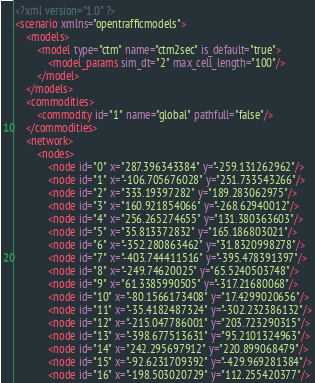<code> <loc_0><loc_0><loc_500><loc_500><_XML_><?xml version="1.0" ?>
<scenario xmlns="opentrafficmodels">
	<models>
		<model type="ctm" name="ctm2sec" is_default="true">
			<model_params sim_dt="2" max_cell_length="100"/>
		</model>
	</models>
	<commodities>
		<commodity id="1" name="global" pathfull="false"/>
	</commodities>
	<network>
		<nodes>
			<node id="0" x="287.396343384" y="-259.131262962"/>
			<node id="1" x="-106.705676028" y="251.733543266"/>
			<node id="2" x="333.19397282" y="189.283062975"/>
			<node id="3" x="160.921854066" y="-268.62940012"/>
			<node id="4" x="256.265274655" y="131.380363603"/>
			<node id="5" x="35.813372832" y="165.186803021"/>
			<node id="6" x="-352.280863462" y="31.8320998278"/>
			<node id="7" x="-403.744411516" y="-395.478391397"/>
			<node id="8" x="-249.74620025" y="65.5240503748"/>
			<node id="9" x="61.3385990505" y="-317.21680068"/>
			<node id="10" x="-80.1566173408" y="17.4299020656"/>
			<node id="11" x="-35.4182487324" y="-302.232386132"/>
			<node id="12" x="-215.047786001" y="203.723290315"/>
			<node id="13" x="-398.677513631" y="95.2101324963"/>
			<node id="14" x="242.295697912" y="220.899068479"/>
			<node id="15" x="-92.6231709392" y="-429.969281384"/>
			<node id="16" x="-198.503020729" y="112.255420377"/></code> 